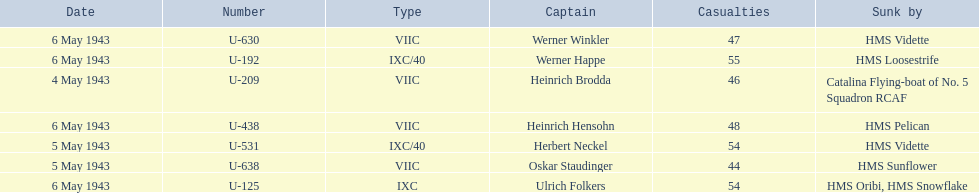Who are the captains of the u boats? Heinrich Brodda, Oskar Staudinger, Herbert Neckel, Werner Happe, Ulrich Folkers, Werner Winkler, Heinrich Hensohn. What are the dates the u boat captains were lost? 4 May 1943, 5 May 1943, 5 May 1943, 6 May 1943, 6 May 1943, 6 May 1943, 6 May 1943. Of these, which were lost on may 5? Oskar Staudinger, Herbert Neckel. Other than oskar staudinger, who else was lost on this day? Herbert Neckel. 